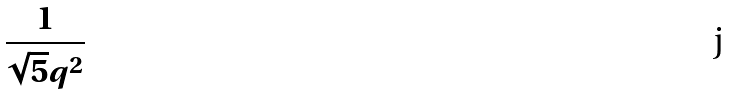Convert formula to latex. <formula><loc_0><loc_0><loc_500><loc_500>\frac { 1 } { \sqrt { 5 } q ^ { 2 } }</formula> 